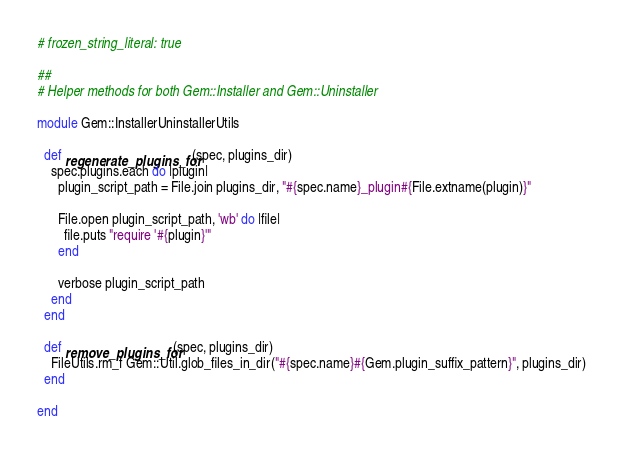Convert code to text. <code><loc_0><loc_0><loc_500><loc_500><_Ruby_># frozen_string_literal: true

##
# Helper methods for both Gem::Installer and Gem::Uninstaller

module Gem::InstallerUninstallerUtils

  def regenerate_plugins_for(spec, plugins_dir)
    spec.plugins.each do |plugin|
      plugin_script_path = File.join plugins_dir, "#{spec.name}_plugin#{File.extname(plugin)}"

      File.open plugin_script_path, 'wb' do |file|
        file.puts "require '#{plugin}'"
      end

      verbose plugin_script_path
    end
  end

  def remove_plugins_for(spec, plugins_dir)
    FileUtils.rm_f Gem::Util.glob_files_in_dir("#{spec.name}#{Gem.plugin_suffix_pattern}", plugins_dir)
  end

end
</code> 